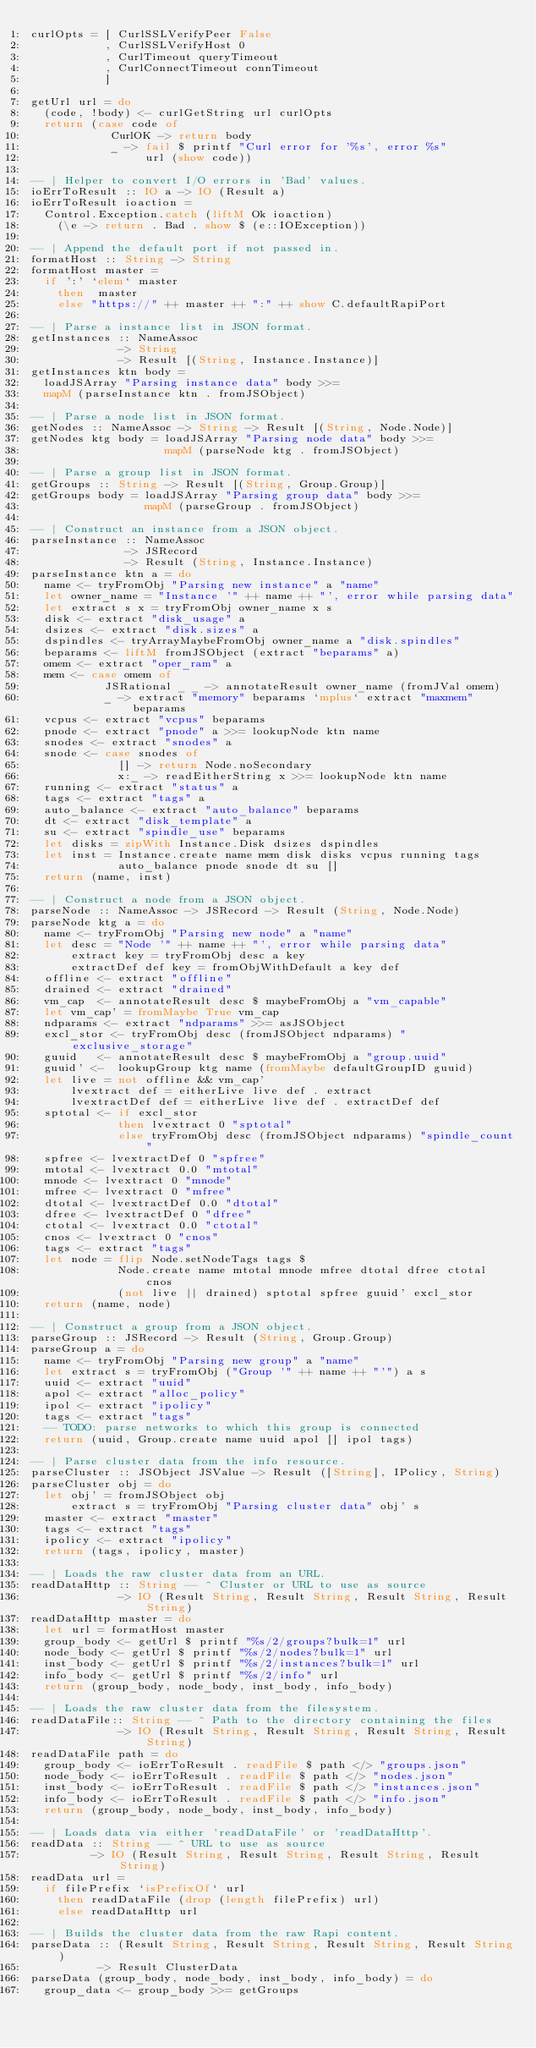<code> <loc_0><loc_0><loc_500><loc_500><_Haskell_>curlOpts = [ CurlSSLVerifyPeer False
           , CurlSSLVerifyHost 0
           , CurlTimeout queryTimeout
           , CurlConnectTimeout connTimeout
           ]

getUrl url = do
  (code, !body) <- curlGetString url curlOpts
  return (case code of
            CurlOK -> return body
            _ -> fail $ printf "Curl error for '%s', error %s"
                 url (show code))

-- | Helper to convert I/O errors in 'Bad' values.
ioErrToResult :: IO a -> IO (Result a)
ioErrToResult ioaction =
  Control.Exception.catch (liftM Ok ioaction)
    (\e -> return . Bad . show $ (e::IOException))

-- | Append the default port if not passed in.
formatHost :: String -> String
formatHost master =
  if ':' `elem` master
    then  master
    else "https://" ++ master ++ ":" ++ show C.defaultRapiPort

-- | Parse a instance list in JSON format.
getInstances :: NameAssoc
             -> String
             -> Result [(String, Instance.Instance)]
getInstances ktn body =
  loadJSArray "Parsing instance data" body >>=
  mapM (parseInstance ktn . fromJSObject)

-- | Parse a node list in JSON format.
getNodes :: NameAssoc -> String -> Result [(String, Node.Node)]
getNodes ktg body = loadJSArray "Parsing node data" body >>=
                    mapM (parseNode ktg . fromJSObject)

-- | Parse a group list in JSON format.
getGroups :: String -> Result [(String, Group.Group)]
getGroups body = loadJSArray "Parsing group data" body >>=
                 mapM (parseGroup . fromJSObject)

-- | Construct an instance from a JSON object.
parseInstance :: NameAssoc
              -> JSRecord
              -> Result (String, Instance.Instance)
parseInstance ktn a = do
  name <- tryFromObj "Parsing new instance" a "name"
  let owner_name = "Instance '" ++ name ++ "', error while parsing data"
  let extract s x = tryFromObj owner_name x s
  disk <- extract "disk_usage" a
  dsizes <- extract "disk.sizes" a
  dspindles <- tryArrayMaybeFromObj owner_name a "disk.spindles"
  beparams <- liftM fromJSObject (extract "beparams" a)
  omem <- extract "oper_ram" a
  mem <- case omem of
           JSRational _ _ -> annotateResult owner_name (fromJVal omem)
           _ -> extract "memory" beparams `mplus` extract "maxmem" beparams
  vcpus <- extract "vcpus" beparams
  pnode <- extract "pnode" a >>= lookupNode ktn name
  snodes <- extract "snodes" a
  snode <- case snodes of
             [] -> return Node.noSecondary
             x:_ -> readEitherString x >>= lookupNode ktn name
  running <- extract "status" a
  tags <- extract "tags" a
  auto_balance <- extract "auto_balance" beparams
  dt <- extract "disk_template" a
  su <- extract "spindle_use" beparams
  let disks = zipWith Instance.Disk dsizes dspindles
  let inst = Instance.create name mem disk disks vcpus running tags
             auto_balance pnode snode dt su []
  return (name, inst)

-- | Construct a node from a JSON object.
parseNode :: NameAssoc -> JSRecord -> Result (String, Node.Node)
parseNode ktg a = do
  name <- tryFromObj "Parsing new node" a "name"
  let desc = "Node '" ++ name ++ "', error while parsing data"
      extract key = tryFromObj desc a key
      extractDef def key = fromObjWithDefault a key def
  offline <- extract "offline"
  drained <- extract "drained"
  vm_cap  <- annotateResult desc $ maybeFromObj a "vm_capable"
  let vm_cap' = fromMaybe True vm_cap
  ndparams <- extract "ndparams" >>= asJSObject
  excl_stor <- tryFromObj desc (fromJSObject ndparams) "exclusive_storage"
  guuid   <- annotateResult desc $ maybeFromObj a "group.uuid"
  guuid' <-  lookupGroup ktg name (fromMaybe defaultGroupID guuid)
  let live = not offline && vm_cap'
      lvextract def = eitherLive live def . extract
      lvextractDef def = eitherLive live def . extractDef def
  sptotal <- if excl_stor
             then lvextract 0 "sptotal"
             else tryFromObj desc (fromJSObject ndparams) "spindle_count"
  spfree <- lvextractDef 0 "spfree"
  mtotal <- lvextract 0.0 "mtotal"
  mnode <- lvextract 0 "mnode"
  mfree <- lvextract 0 "mfree"
  dtotal <- lvextractDef 0.0 "dtotal"
  dfree <- lvextractDef 0 "dfree"
  ctotal <- lvextract 0.0 "ctotal"
  cnos <- lvextract 0 "cnos"
  tags <- extract "tags"
  let node = flip Node.setNodeTags tags $
             Node.create name mtotal mnode mfree dtotal dfree ctotal cnos
             (not live || drained) sptotal spfree guuid' excl_stor
  return (name, node)

-- | Construct a group from a JSON object.
parseGroup :: JSRecord -> Result (String, Group.Group)
parseGroup a = do
  name <- tryFromObj "Parsing new group" a "name"
  let extract s = tryFromObj ("Group '" ++ name ++ "'") a s
  uuid <- extract "uuid"
  apol <- extract "alloc_policy"
  ipol <- extract "ipolicy"
  tags <- extract "tags"
  -- TODO: parse networks to which this group is connected
  return (uuid, Group.create name uuid apol [] ipol tags)

-- | Parse cluster data from the info resource.
parseCluster :: JSObject JSValue -> Result ([String], IPolicy, String)
parseCluster obj = do
  let obj' = fromJSObject obj
      extract s = tryFromObj "Parsing cluster data" obj' s
  master <- extract "master"
  tags <- extract "tags"
  ipolicy <- extract "ipolicy"
  return (tags, ipolicy, master)

-- | Loads the raw cluster data from an URL.
readDataHttp :: String -- ^ Cluster or URL to use as source
             -> IO (Result String, Result String, Result String, Result String)
readDataHttp master = do
  let url = formatHost master
  group_body <- getUrl $ printf "%s/2/groups?bulk=1" url
  node_body <- getUrl $ printf "%s/2/nodes?bulk=1" url
  inst_body <- getUrl $ printf "%s/2/instances?bulk=1" url
  info_body <- getUrl $ printf "%s/2/info" url
  return (group_body, node_body, inst_body, info_body)

-- | Loads the raw cluster data from the filesystem.
readDataFile:: String -- ^ Path to the directory containing the files
             -> IO (Result String, Result String, Result String, Result String)
readDataFile path = do
  group_body <- ioErrToResult . readFile $ path </> "groups.json"
  node_body <- ioErrToResult . readFile $ path </> "nodes.json"
  inst_body <- ioErrToResult . readFile $ path </> "instances.json"
  info_body <- ioErrToResult . readFile $ path </> "info.json"
  return (group_body, node_body, inst_body, info_body)

-- | Loads data via either 'readDataFile' or 'readDataHttp'.
readData :: String -- ^ URL to use as source
         -> IO (Result String, Result String, Result String, Result String)
readData url =
  if filePrefix `isPrefixOf` url
    then readDataFile (drop (length filePrefix) url)
    else readDataHttp url

-- | Builds the cluster data from the raw Rapi content.
parseData :: (Result String, Result String, Result String, Result String)
          -> Result ClusterData
parseData (group_body, node_body, inst_body, info_body) = do
  group_data <- group_body >>= getGroups</code> 